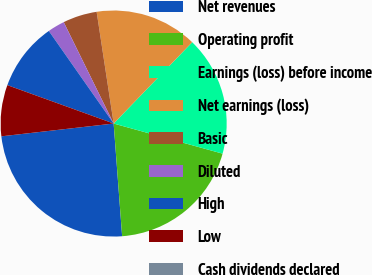Convert chart to OTSL. <chart><loc_0><loc_0><loc_500><loc_500><pie_chart><fcel>Net revenues<fcel>Operating profit<fcel>Earnings (loss) before income<fcel>Net earnings (loss)<fcel>Basic<fcel>Diluted<fcel>High<fcel>Low<fcel>Cash dividends declared<nl><fcel>24.39%<fcel>19.51%<fcel>17.07%<fcel>14.63%<fcel>4.88%<fcel>2.44%<fcel>9.76%<fcel>7.32%<fcel>0.0%<nl></chart> 